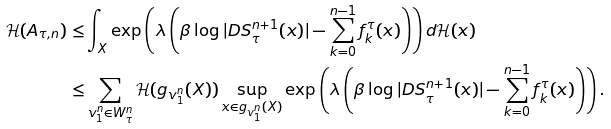<formula> <loc_0><loc_0><loc_500><loc_500>\mathcal { H } ( A _ { \tau , n } ) \leq & \int _ { X } \exp \left ( \lambda \left ( \beta \log | D S ^ { n + 1 } _ { \tau } ( x ) | - \sum _ { k = 0 } ^ { n - 1 } f _ { k } ^ { \tau } ( x ) \right ) \right ) d \mathcal { H } ( x ) \\ \leq & \sum _ { v _ { 1 } ^ { n } \in W _ { \tau } ^ { n } } \mathcal { H } ( g _ { v _ { 1 } ^ { n } } ( X ) ) \sup _ { x \in g _ { v _ { 1 } ^ { n } } ( X ) } \exp \left ( \lambda \left ( \beta \log | D S ^ { n + 1 } _ { \tau } ( x ) | - \sum _ { k = 0 } ^ { n - 1 } f _ { k } ^ { \tau } ( x ) \right ) \right ) .</formula> 